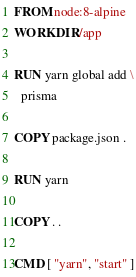<code> <loc_0><loc_0><loc_500><loc_500><_Dockerfile_>FROM node:8-alpine
WORKDIR /app

RUN yarn global add \
  prisma

COPY package.json .

RUN yarn

COPY . .

CMD [ "yarn", "start" ]
</code> 